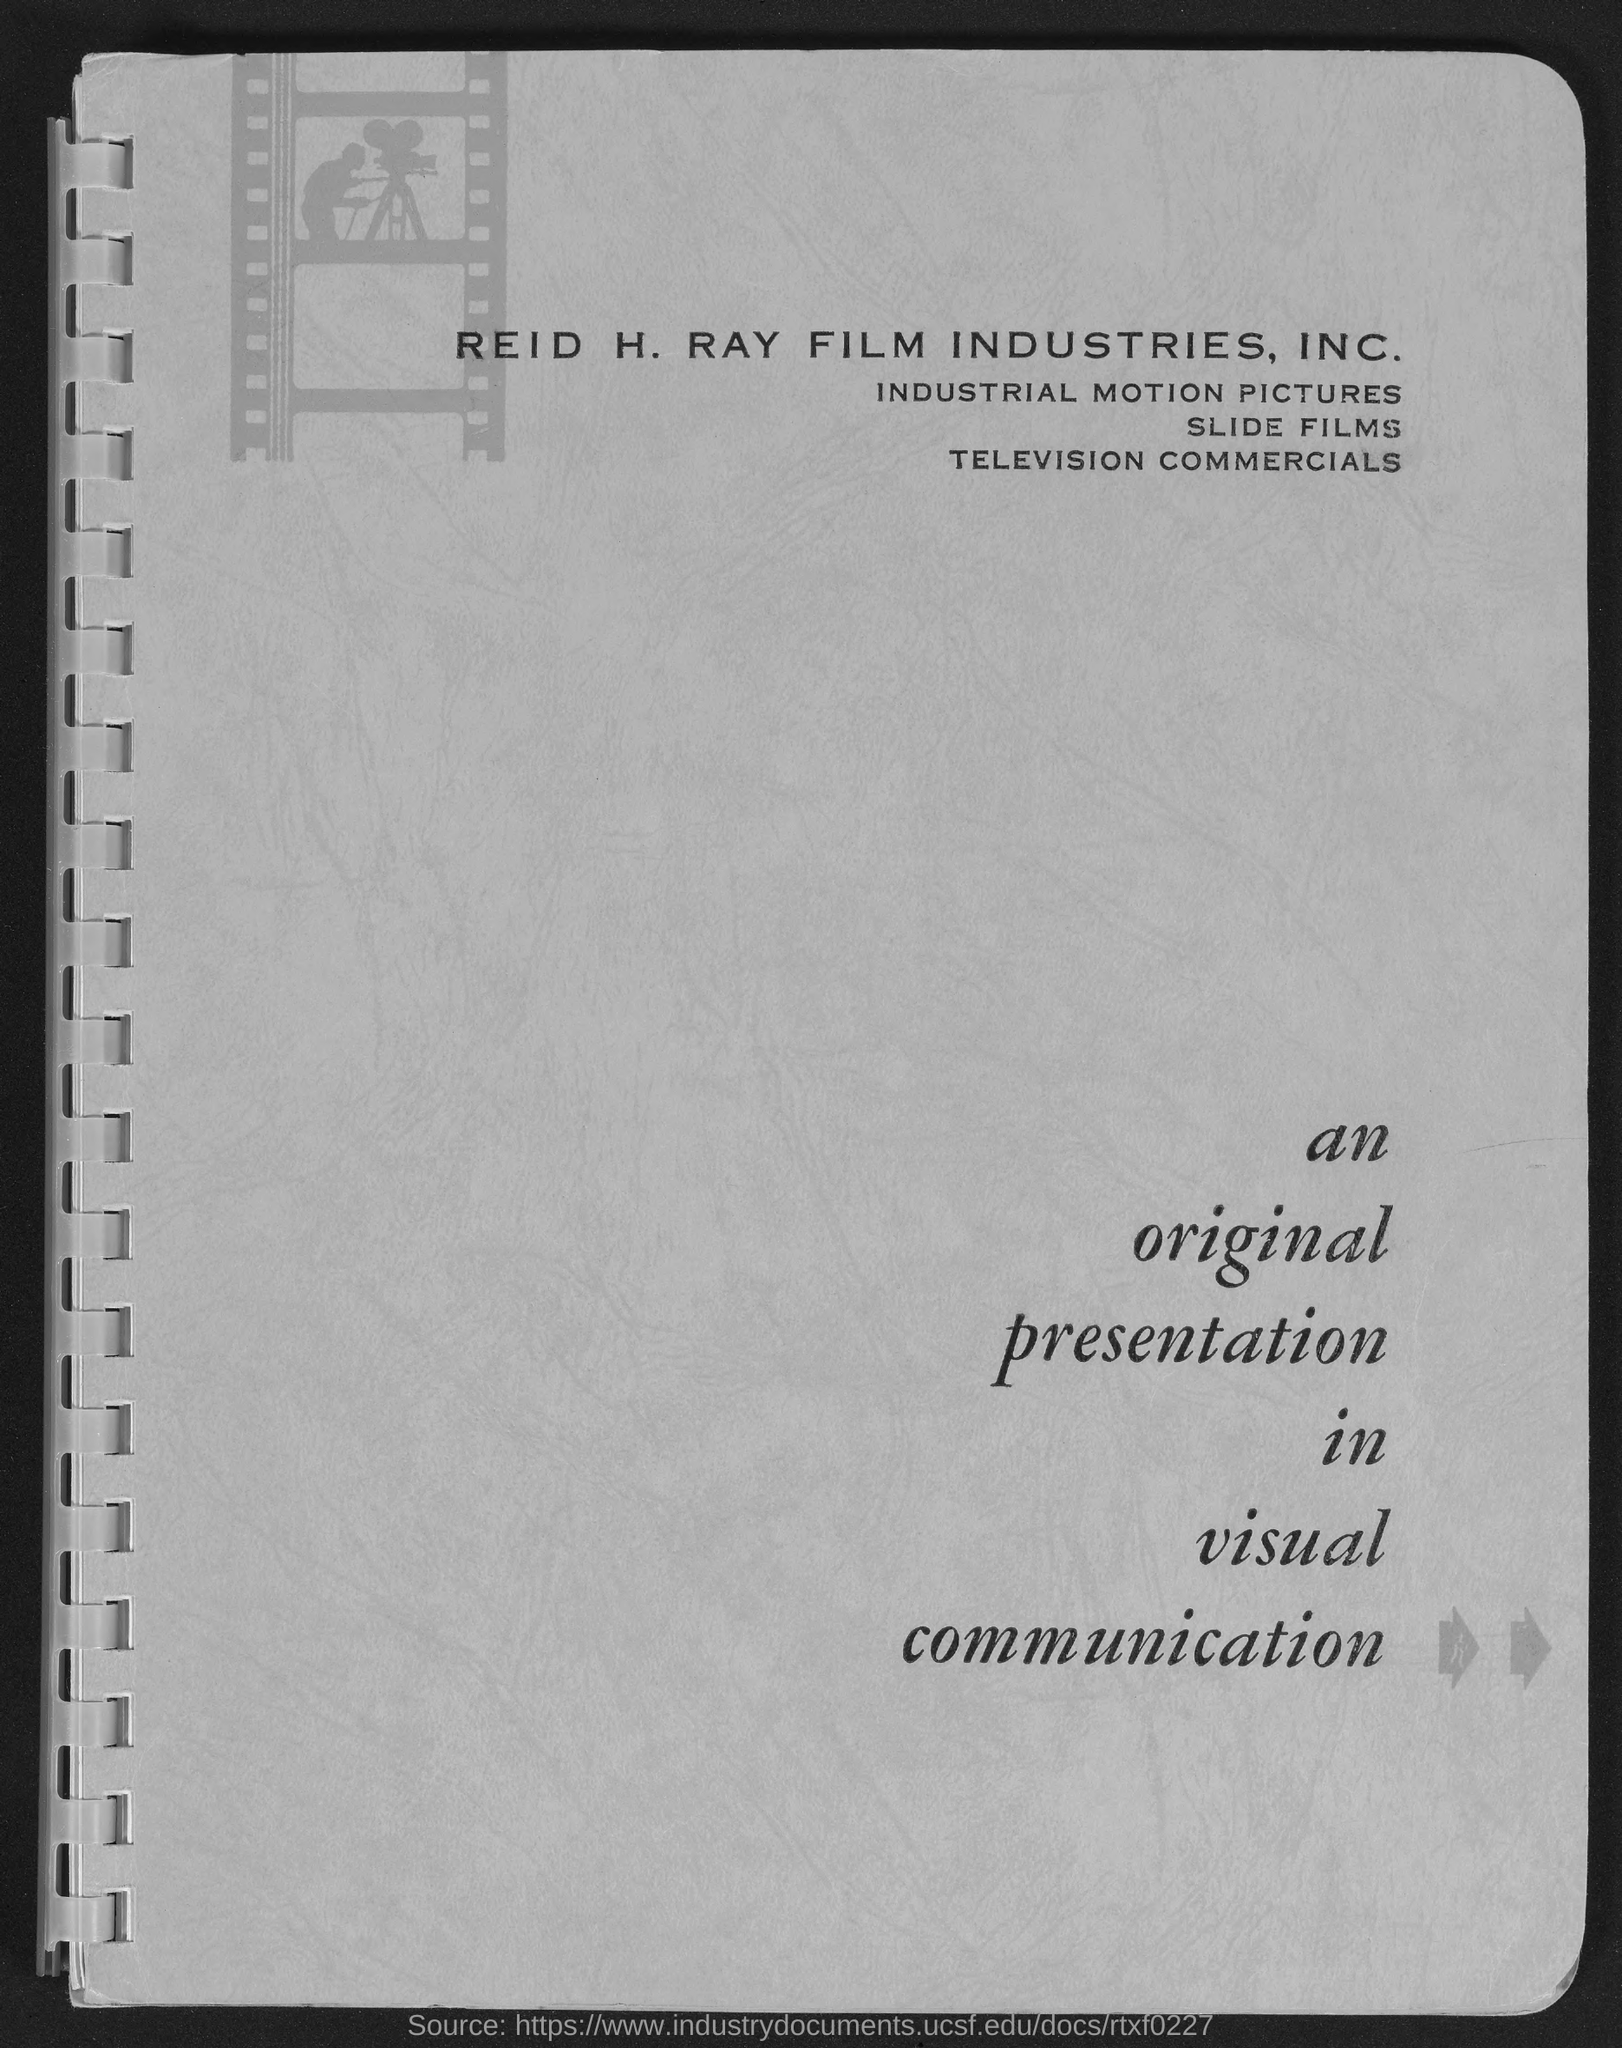What is the title of the page?
Your answer should be compact. An original presentation in visual communication. 